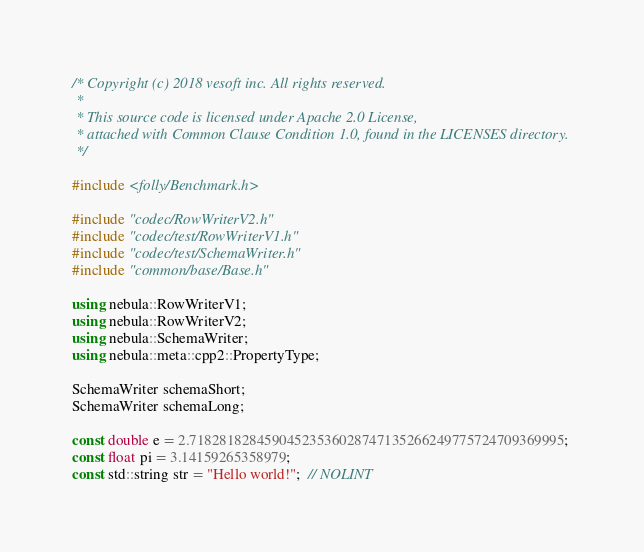<code> <loc_0><loc_0><loc_500><loc_500><_C++_>/* Copyright (c) 2018 vesoft inc. All rights reserved.
 *
 * This source code is licensed under Apache 2.0 License,
 * attached with Common Clause Condition 1.0, found in the LICENSES directory.
 */

#include <folly/Benchmark.h>

#include "codec/RowWriterV2.h"
#include "codec/test/RowWriterV1.h"
#include "codec/test/SchemaWriter.h"
#include "common/base/Base.h"

using nebula::RowWriterV1;
using nebula::RowWriterV2;
using nebula::SchemaWriter;
using nebula::meta::cpp2::PropertyType;

SchemaWriter schemaShort;
SchemaWriter schemaLong;

const double e = 2.71828182845904523536028747135266249775724709369995;
const float pi = 3.14159265358979;
const std::string str = "Hello world!";  // NOLINT
</code> 